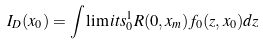<formula> <loc_0><loc_0><loc_500><loc_500>I _ { D } ( x _ { 0 } ) = \int \lim i t s _ { 0 } ^ { 1 } R ( 0 , x _ { m } ) f _ { 0 } ( z , x _ { 0 } ) d z</formula> 